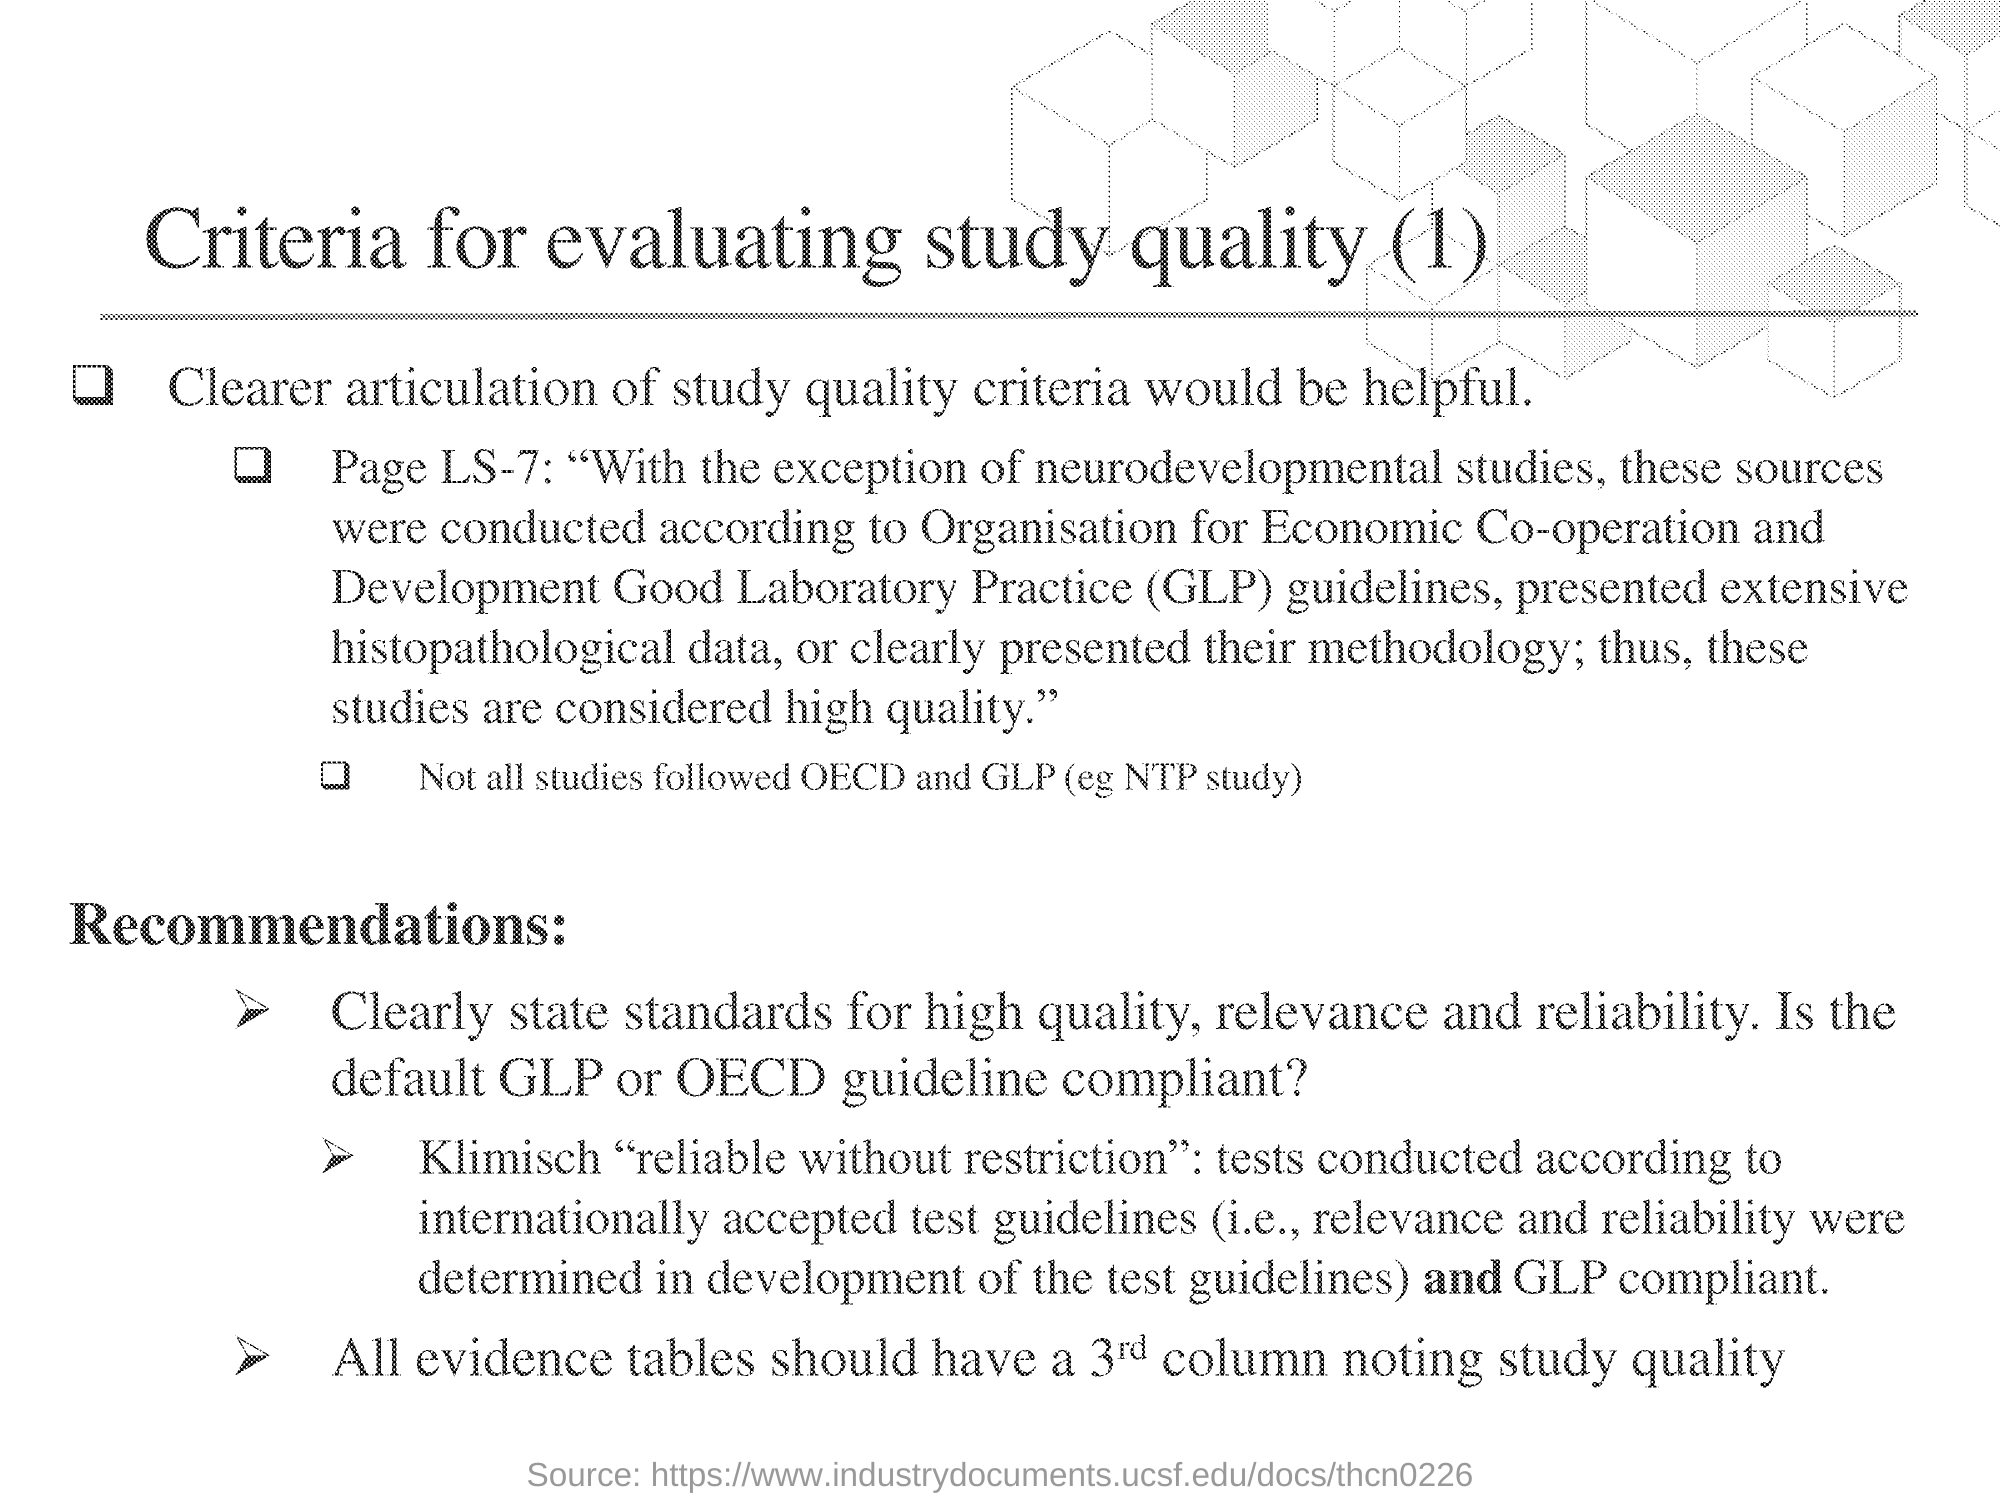Outline some significant characteristics in this image. The title of the document is 'Criteria for evaluating study quality.' Good Laboratory Practice (GLP) is a set of standards and guidelines that are used to ensure the quality and integrity of laboratory testing and research. 